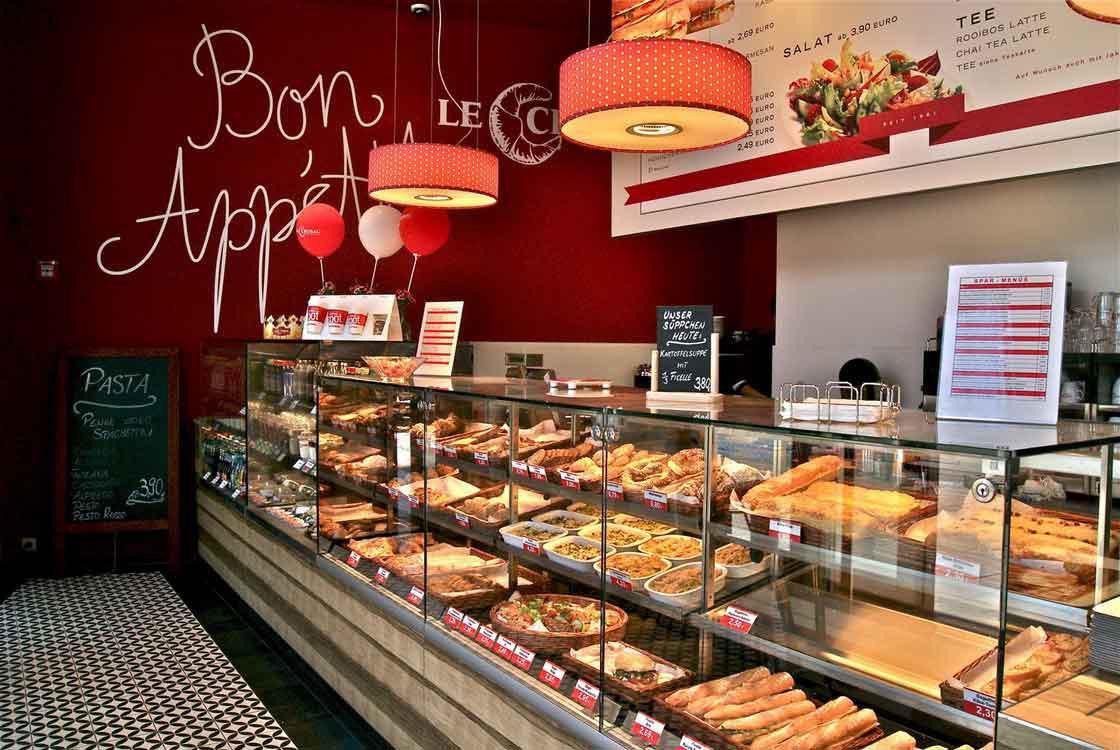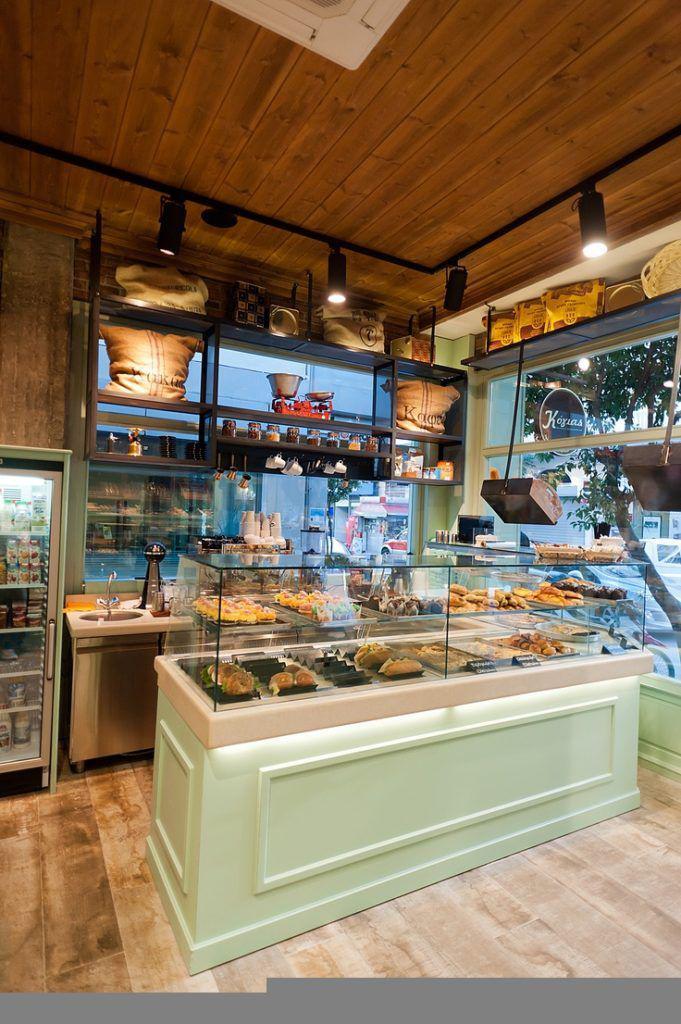The first image is the image on the left, the second image is the image on the right. Analyze the images presented: Is the assertion "There are hanging lights above the counter in one of the images." valid? Answer yes or no. Yes. The first image is the image on the left, the second image is the image on the right. Given the left and right images, does the statement "One image shows a small seating area for customers." hold true? Answer yes or no. No. 